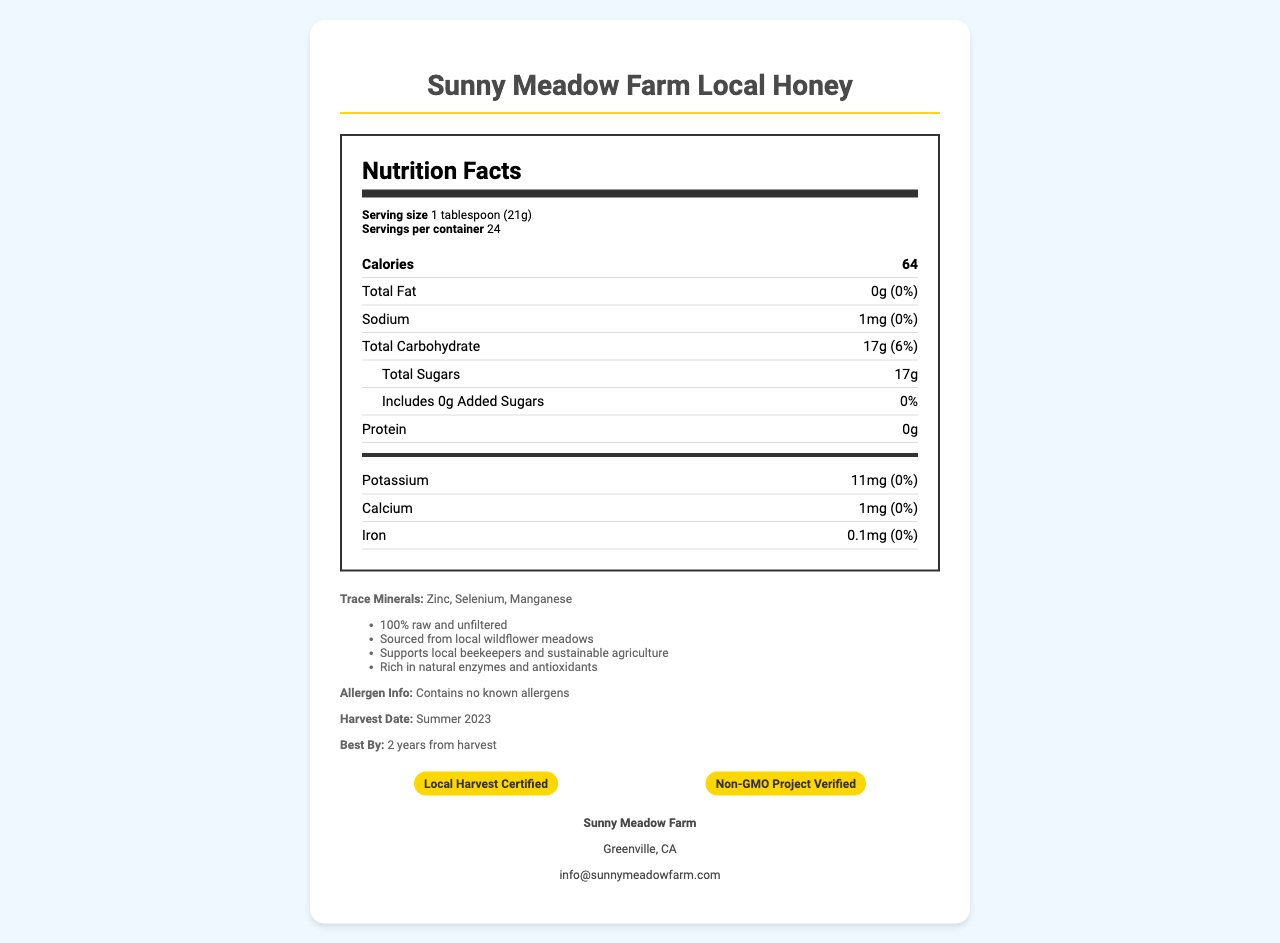what is the serving size of Sunny Meadow Farm Local Honey? The serving size is clearly specified as "1 tablespoon (21g)" on the document.
Answer: 1 tablespoon (21g) how many servings are in one container of this honey? The document states "Servings per container: 24".
Answer: 24 how many calories are in one serving? The document lists the calorie count as "Calories: 64".
Answer: 64 what is the total amount of sugars in a serving? Under the Total Sugars section, the document specifies "17g" for sugar content.
Answer: 17g does Sunny Meadow Farm Local Honey contain any added sugars? The document states "Includes 0g Added Sugars", indicating there are no added sugars.
Answer: No which trace minerals are found in this honey? A. Zinc and Magnesium B. Selenium and Calcium C. Zinc, Selenium, and Manganese The Trace Minerals section lists "Zinc, Selenium, and Manganese" as the trace minerals present.
Answer: C where is Sunny Meadow Farm located? A. Springfield, IL B. Greenville, CA C. Madison, WI The Producer Info section states the location as "Greenville, CA".
Answer: B is this honey non-GMO? The document includes the certification "Non-GMO Project Verified".
Answer: Yes is there any allergen information provided? In the Additional Info section, it mentions "Contains no known allergens".
Answer: Yes what additional benefits does the honey provide? The Additional Info section lists these benefits specifically.
Answer: 100% raw and unfiltered, sourced from local wildflower meadows, supports local beekeepers and sustainable agriculture, rich in natural enzymes and antioxidants what certifications does the product hold? The certifications are listed as "Local Harvest Certified" and "Non-GMO Project Verified".
Answer: Local Harvest Certified and Non-GMO Project Verified when is the best by date for this honey? The document specifies the best by date as "2 years from harvest".
Answer: 2 years from harvest how much sodium is in each serving? The Sodium section lists the sodium amount as "1mg".
Answer: 1mg what is the main source of the honey? The document mentions the honey is "sourced from local wildflower meadows".
Answer: Locally-produced from wildflower meadows what is the contact email for Sunny Meadow Farm? The Producer Info section provides "info@sunnymeadowfarm.com" as the contact.
Answer: info@sunnymeadowfarm.com how much potassium is in the honey? The document lists potassium as "11mg" under Vitamins and Minerals.
Answer: 11mg summarize the key information provided in the document. The document provides detailed nutritional information, sourcing details, and additional benefits such as certifications and support for local agriculture, along with producer contact information.
Answer: Sunny Meadow Farm Local Honey offers 24 servings of 1 tablespoon each, with 64 calories per serving. It does not contain fat, added sugars, or allergens. It is sourced from local wildflower meadows and supports sustainable agriculture. The honey is rich in natural enzymes and antioxidants and contains trace minerals like Zinc, Selenium, and Manganese. It has certifications such as Local Harvest Certified and Non-GMO Project Verified. It is produced in Greenville, CA, with a harvest date of Summer 2023 and a best by date of two years from the harvest. how many grams of protein are in one serving? The Protein section clearly states "0g" under protein.
Answer: 0g which vitamins and minerals are included in the honey? The Vitamins and Minerals section lists "Potassium", "Calcium", and "Iron".
Answer: Potassium, Calcium, Iron how much calcium is in one serving? The document lists calcium under Vitamins and Minerals as "1mg".
Answer: 1mg what flavors or floral sources does the honey have? The document does not provide information about specific flavors or floral sources beyond "local wildflower meadows".
Answer: Cannot be determined 